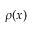<formula> <loc_0><loc_0><loc_500><loc_500>\rho ( x )</formula> 